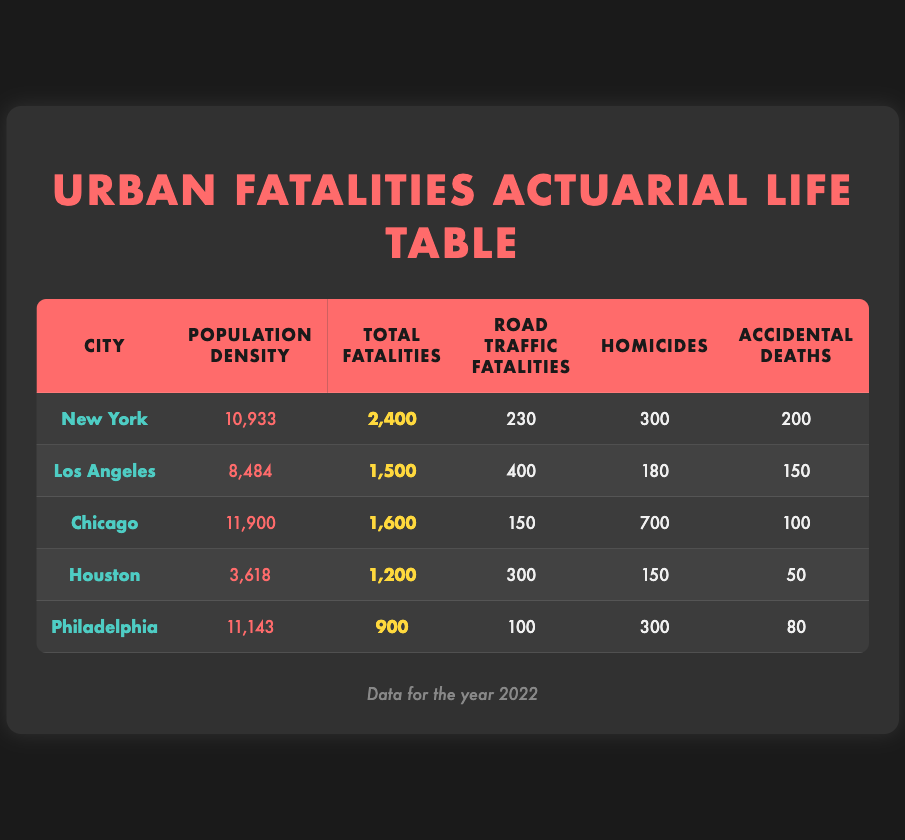What is the population density of New York? The table lists the population density for New York as 10,933.
Answer: 10,933 How many total fatalities occurred in Chicago? According to the table, Chicago had a total of 1,600 fatalities.
Answer: 1,600 Which city has the highest number of road traffic fatalities, and what is that number? By comparing the road traffic fatalities column, Los Angeles has the highest number at 400.
Answer: Los Angeles, 400 Is the total fatalities count in Philadelphia greater than that in Houston? The table shows Philadelphia with 900 fatalities and Houston with 1,200 fatalities; thus, this statement is false.
Answer: No What is the difference in total fatalities between New York and Los Angeles? New York had 2,400 total fatalities, while Los Angeles had 1,500. The difference is 2,400 - 1,500 = 900.
Answer: 900 What is the average population density of the cities presented in the table? To find the average, add all population densities (10,933 + 8,484 + 11,900 + 3,618 + 11,143 = 45,078) and divide by the number of cities (5): 45,078 / 5 = 9,015.6.
Answer: 9,015.6 Does Chicago have more homicides than New York? Chicago's homicide count is 700 while New York's is 300, indicating that Chicago has more homicides.
Answer: Yes Which city has the lowest number of accidental deaths, and what is that number? Looking at the accidental deaths column, Houston has the lowest with 50 accidental deaths.
Answer: Houston, 50 What percentage of total fatalities in Los Angeles are due to road traffic? The total fatalities in Los Angeles are 1,500, with 400 due to road traffic. The percentage is (400 / 1,500) * 100 = 26.67%.
Answer: 26.67% 